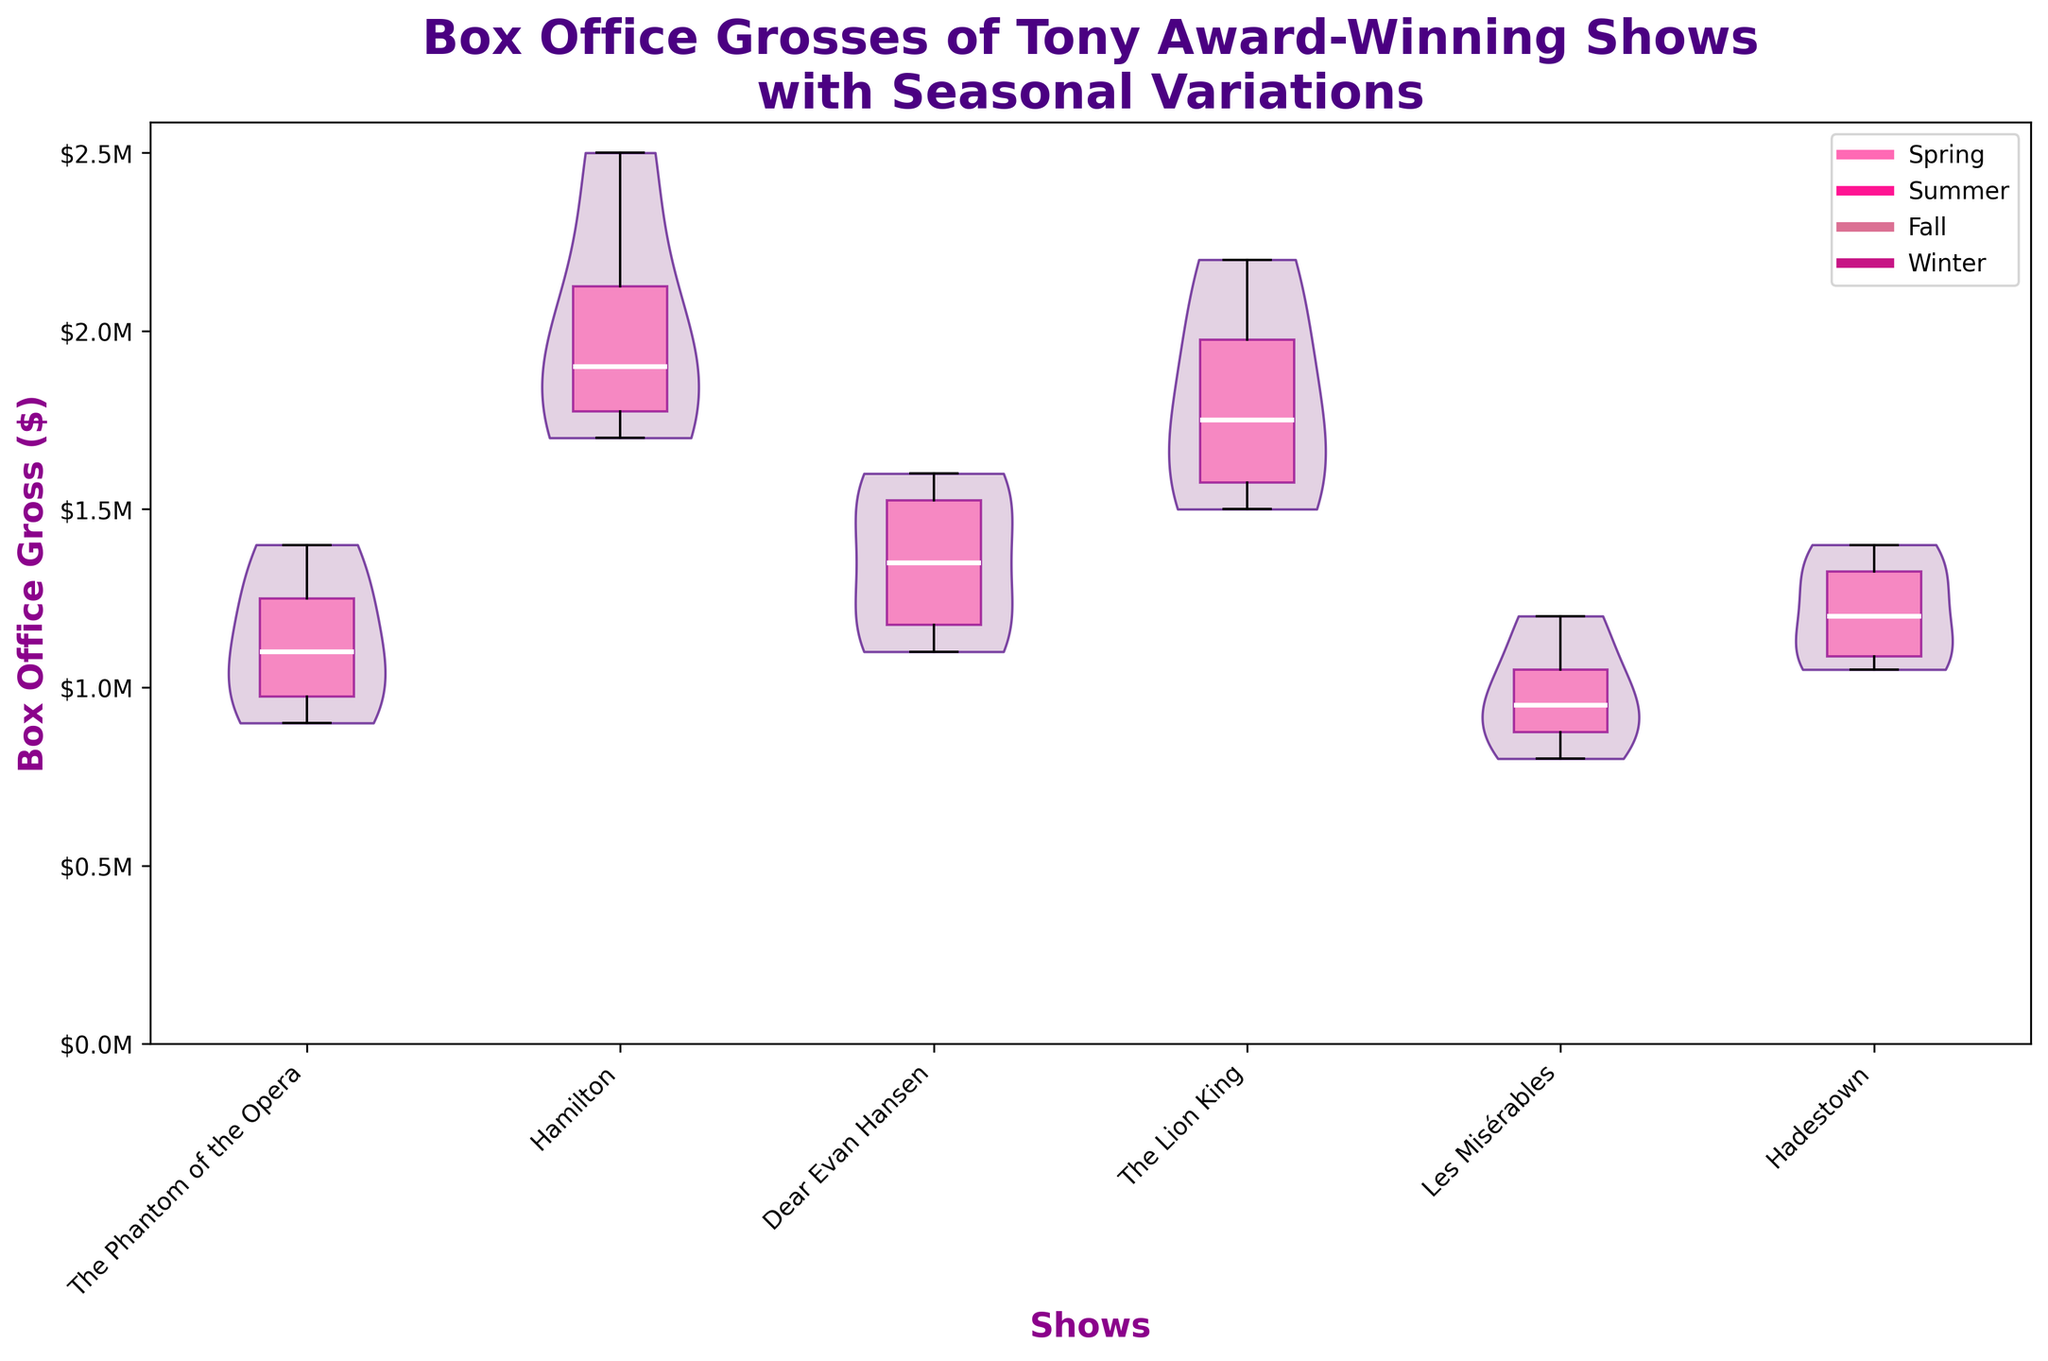What is the title of the plot? The title of the plot is located at the top and provides a summary of what the plot represents. You can read it directly from there.
Answer: Box Office Grosses of Tony Award-Winning Shows with Seasonal Variations Which show has the highest median box office gross according to the overlay box plot? To find the highest median box office gross, look for the white line within the colored boxes of each show. Identify which show has the highest white line.
Answer: Hamilton How many shows are represented in this plot? Count the number of distinct shows listed on the x-axis labels.
Answer: 6 Which season has the lowest median box office gross for "Les Misérables"? Locate the box plots for "Les Misérables" and identify the lowest white line within those boxes, then check the corresponding season in the plot legend.
Answer: Winter Is the median box office gross for "The Lion King" higher in Summer compared to Winter? Compare the white lines within the boxes for "The Lion King" in Summer and Winter to determine which is higher.
Answer: Yes Which show demonstrates the greatest range in box office grosses? Look at the length of the violin plots for each show. The show with the longest spread indicates the greatest range.
Answer: Hamilton What is the range of the box office gross for "Dear Evan Hansen" in Spring? Identify the lowest and highest points within the Spring section of the "Dear Evan Hansen" violin plot and subtract the lowest value from the highest value.
Answer: $1.2M to $1.5M Among all shows, which one has the most consistent box office gross across all seasons? Look for the show with the narrowest violin plot and the least variation in the box plot whiskers.
Answer: The Phantom of the Opera How do the box office grosses for "Hadestown" vary across different seasons? Observe the "Hadestown" violin plot and summarize whether there is a gradual change or abrupt jumps across seasons.
Answer: Moderately consistent with slight increases during Spring and Summer What visual patterns are evident in the box office grosses during Summer season for most shows? Examine the Summer section in each violin plot and describe a general trend about the box office grosses in Summer.
Answer: Generally higher gross 